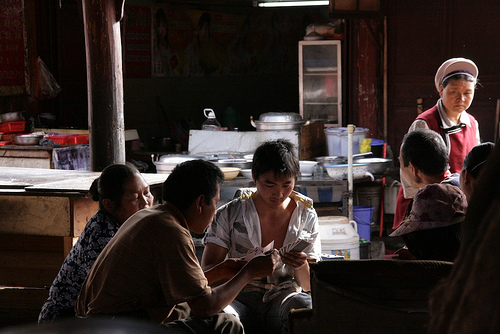<image>
Is there a man on the lady? No. The man is not positioned on the lady. They may be near each other, but the man is not supported by or resting on top of the lady. 